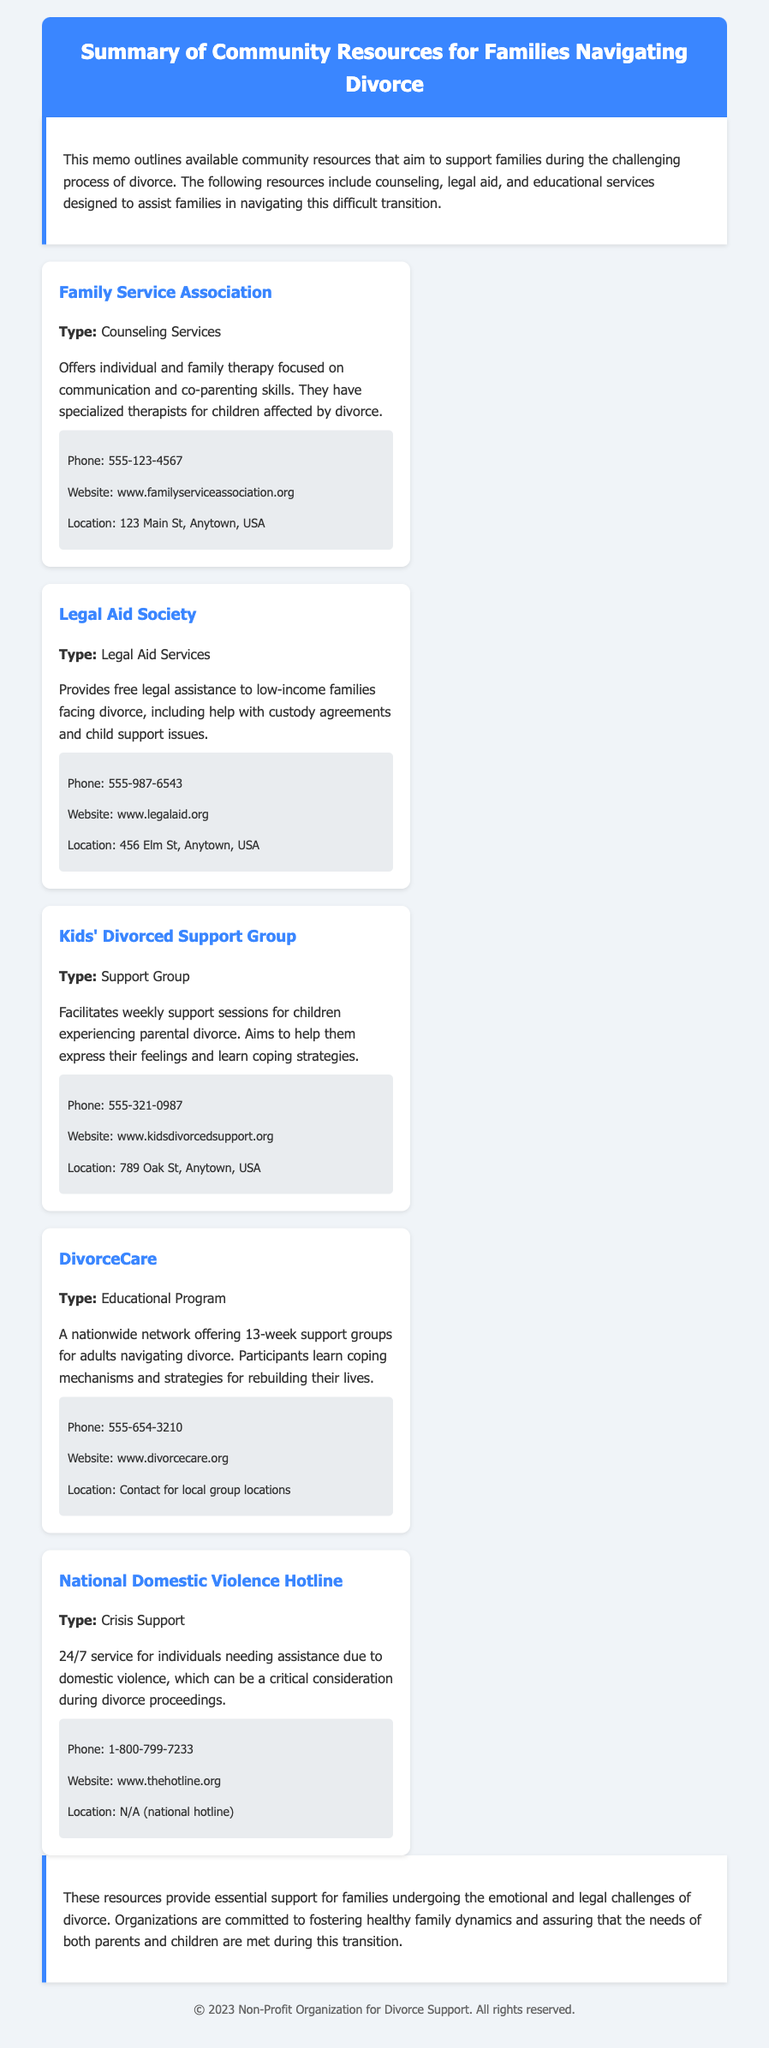What is the name of the counseling service? The counseling service mentioned in the document is the Family Service Association.
Answer: Family Service Association What type of service does the Legal Aid Society provide? The Legal Aid Society offers free legal assistance to low-income families facing divorce.
Answer: Legal Aid Services What is the phone number for the Kids' Divorced Support Group? The contact information includes a phone number to reach the Kids' Divorced Support Group, which is 555-321-0987.
Answer: 555-321-0987 How long is the DivorceCare program? The DivorceCare program is a 13-week support group for adults.
Answer: 13 weeks What crucial issue does the National Domestic Violence Hotline address? The National Domestic Violence Hotline provides crisis support for individuals needing assistance due to domestic violence.
Answer: Domestic Violence What are the goals of the Family Service Association? The Family Service Association focuses on communication and co-parenting skills to help families.
Answer: Communication and co-parenting skills Which organization facilitates weekly support sessions for children? The Kids' Divorced Support Group facilitates weekly support sessions for children experiencing parental divorce.
Answer: Kids' Divorced Support Group What does DivorceCare help participants learn? DivorceCare helps participants learn coping mechanisms and strategies for rebuilding their lives.
Answer: Coping mechanisms and strategies for rebuilding their lives 